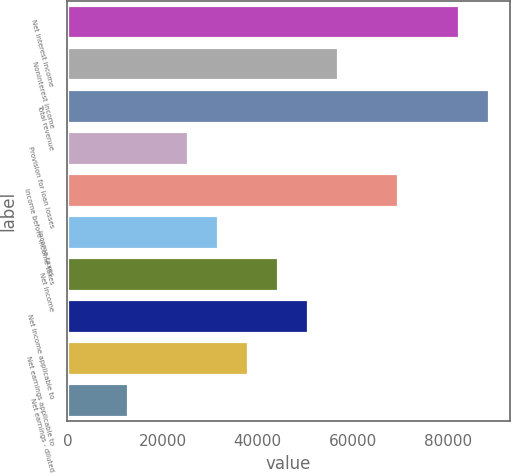<chart> <loc_0><loc_0><loc_500><loc_500><bar_chart><fcel>Net interest income<fcel>Noninterest income<fcel>Total revenue<fcel>Provision for loan losses<fcel>Income before income taxes<fcel>Income taxes<fcel>Net income<fcel>Net income applicable to<fcel>Net earnings applicable to<fcel>Net earnings - diluted<nl><fcel>82210.6<fcel>56915.1<fcel>88534.5<fcel>25295.8<fcel>69562.9<fcel>31619.6<fcel>44267.4<fcel>50591.2<fcel>37943.5<fcel>12648<nl></chart> 